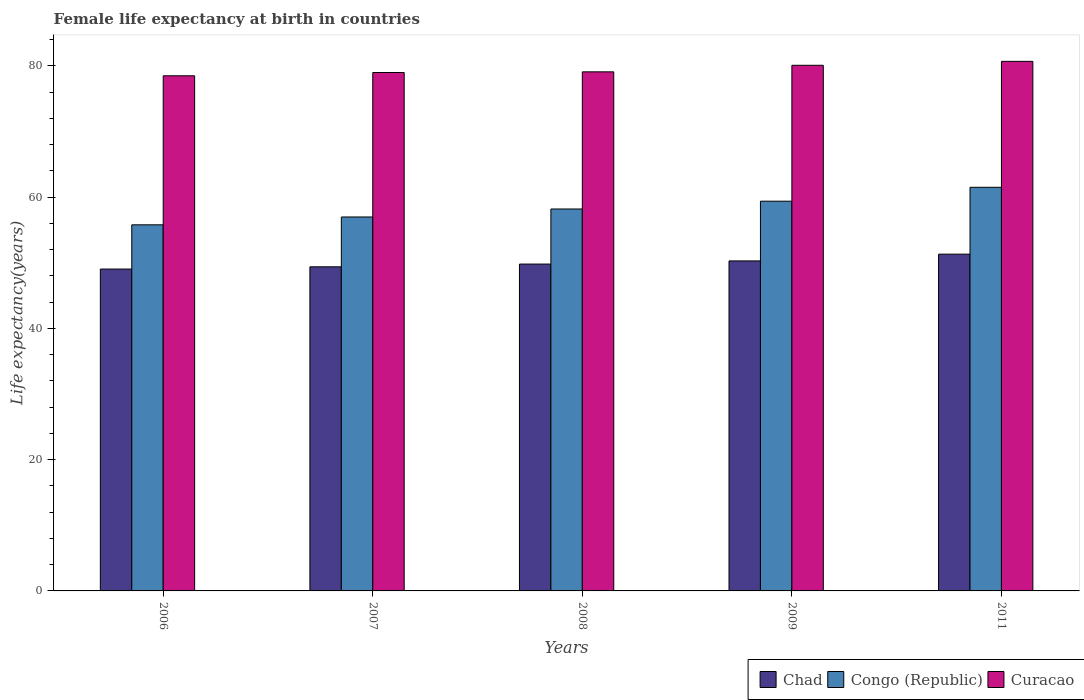How many different coloured bars are there?
Make the answer very short. 3. How many groups of bars are there?
Offer a very short reply. 5. Are the number of bars per tick equal to the number of legend labels?
Make the answer very short. Yes. How many bars are there on the 3rd tick from the left?
Offer a very short reply. 3. How many bars are there on the 2nd tick from the right?
Make the answer very short. 3. What is the label of the 3rd group of bars from the left?
Ensure brevity in your answer.  2008. In how many cases, is the number of bars for a given year not equal to the number of legend labels?
Provide a short and direct response. 0. What is the female life expectancy at birth in Congo (Republic) in 2011?
Give a very brief answer. 61.51. Across all years, what is the maximum female life expectancy at birth in Congo (Republic)?
Offer a very short reply. 61.51. Across all years, what is the minimum female life expectancy at birth in Chad?
Offer a very short reply. 49.05. In which year was the female life expectancy at birth in Curacao maximum?
Your answer should be compact. 2011. In which year was the female life expectancy at birth in Congo (Republic) minimum?
Give a very brief answer. 2006. What is the total female life expectancy at birth in Chad in the graph?
Your answer should be very brief. 249.86. What is the difference between the female life expectancy at birth in Congo (Republic) in 2006 and that in 2009?
Your response must be concise. -3.6. What is the difference between the female life expectancy at birth in Chad in 2007 and the female life expectancy at birth in Curacao in 2009?
Make the answer very short. -30.71. What is the average female life expectancy at birth in Curacao per year?
Offer a very short reply. 79.48. In the year 2009, what is the difference between the female life expectancy at birth in Chad and female life expectancy at birth in Congo (Republic)?
Keep it short and to the point. -9.1. In how many years, is the female life expectancy at birth in Congo (Republic) greater than 44 years?
Make the answer very short. 5. What is the ratio of the female life expectancy at birth in Congo (Republic) in 2007 to that in 2008?
Your response must be concise. 0.98. Is the difference between the female life expectancy at birth in Chad in 2008 and 2011 greater than the difference between the female life expectancy at birth in Congo (Republic) in 2008 and 2011?
Ensure brevity in your answer.  Yes. What is the difference between the highest and the second highest female life expectancy at birth in Curacao?
Offer a very short reply. 0.6. What is the difference between the highest and the lowest female life expectancy at birth in Chad?
Make the answer very short. 2.27. In how many years, is the female life expectancy at birth in Congo (Republic) greater than the average female life expectancy at birth in Congo (Republic) taken over all years?
Offer a very short reply. 2. What does the 2nd bar from the left in 2011 represents?
Make the answer very short. Congo (Republic). What does the 3rd bar from the right in 2008 represents?
Make the answer very short. Chad. How many bars are there?
Offer a terse response. 15. Are all the bars in the graph horizontal?
Provide a succinct answer. No. How many years are there in the graph?
Provide a short and direct response. 5. What is the difference between two consecutive major ticks on the Y-axis?
Provide a succinct answer. 20. Are the values on the major ticks of Y-axis written in scientific E-notation?
Your response must be concise. No. Does the graph contain grids?
Provide a short and direct response. No. Where does the legend appear in the graph?
Provide a succinct answer. Bottom right. How many legend labels are there?
Provide a short and direct response. 3. How are the legend labels stacked?
Offer a very short reply. Horizontal. What is the title of the graph?
Offer a very short reply. Female life expectancy at birth in countries. What is the label or title of the X-axis?
Provide a short and direct response. Years. What is the label or title of the Y-axis?
Ensure brevity in your answer.  Life expectancy(years). What is the Life expectancy(years) in Chad in 2006?
Provide a succinct answer. 49.05. What is the Life expectancy(years) in Congo (Republic) in 2006?
Ensure brevity in your answer.  55.79. What is the Life expectancy(years) in Curacao in 2006?
Ensure brevity in your answer.  78.5. What is the Life expectancy(years) in Chad in 2007?
Offer a very short reply. 49.39. What is the Life expectancy(years) in Congo (Republic) in 2007?
Make the answer very short. 56.98. What is the Life expectancy(years) in Curacao in 2007?
Ensure brevity in your answer.  79. What is the Life expectancy(years) of Chad in 2008?
Your answer should be compact. 49.81. What is the Life expectancy(years) of Congo (Republic) in 2008?
Your response must be concise. 58.2. What is the Life expectancy(years) in Curacao in 2008?
Provide a succinct answer. 79.1. What is the Life expectancy(years) in Chad in 2009?
Your response must be concise. 50.29. What is the Life expectancy(years) in Congo (Republic) in 2009?
Offer a terse response. 59.39. What is the Life expectancy(years) in Curacao in 2009?
Keep it short and to the point. 80.1. What is the Life expectancy(years) in Chad in 2011?
Your answer should be compact. 51.32. What is the Life expectancy(years) of Congo (Republic) in 2011?
Offer a terse response. 61.51. What is the Life expectancy(years) in Curacao in 2011?
Make the answer very short. 80.7. Across all years, what is the maximum Life expectancy(years) of Chad?
Provide a short and direct response. 51.32. Across all years, what is the maximum Life expectancy(years) in Congo (Republic)?
Your response must be concise. 61.51. Across all years, what is the maximum Life expectancy(years) in Curacao?
Provide a succinct answer. 80.7. Across all years, what is the minimum Life expectancy(years) of Chad?
Offer a terse response. 49.05. Across all years, what is the minimum Life expectancy(years) in Congo (Republic)?
Your response must be concise. 55.79. Across all years, what is the minimum Life expectancy(years) in Curacao?
Keep it short and to the point. 78.5. What is the total Life expectancy(years) in Chad in the graph?
Ensure brevity in your answer.  249.86. What is the total Life expectancy(years) in Congo (Republic) in the graph?
Keep it short and to the point. 291.87. What is the total Life expectancy(years) in Curacao in the graph?
Provide a succinct answer. 397.4. What is the difference between the Life expectancy(years) of Chad in 2006 and that in 2007?
Ensure brevity in your answer.  -0.34. What is the difference between the Life expectancy(years) in Congo (Republic) in 2006 and that in 2007?
Keep it short and to the point. -1.2. What is the difference between the Life expectancy(years) in Curacao in 2006 and that in 2007?
Offer a very short reply. -0.5. What is the difference between the Life expectancy(years) in Chad in 2006 and that in 2008?
Your answer should be very brief. -0.76. What is the difference between the Life expectancy(years) in Congo (Republic) in 2006 and that in 2008?
Make the answer very short. -2.41. What is the difference between the Life expectancy(years) of Curacao in 2006 and that in 2008?
Provide a short and direct response. -0.6. What is the difference between the Life expectancy(years) of Chad in 2006 and that in 2009?
Your answer should be very brief. -1.24. What is the difference between the Life expectancy(years) of Congo (Republic) in 2006 and that in 2009?
Your response must be concise. -3.6. What is the difference between the Life expectancy(years) in Chad in 2006 and that in 2011?
Your answer should be very brief. -2.27. What is the difference between the Life expectancy(years) of Congo (Republic) in 2006 and that in 2011?
Provide a short and direct response. -5.72. What is the difference between the Life expectancy(years) in Chad in 2007 and that in 2008?
Provide a succinct answer. -0.42. What is the difference between the Life expectancy(years) in Congo (Republic) in 2007 and that in 2008?
Keep it short and to the point. -1.22. What is the difference between the Life expectancy(years) of Curacao in 2007 and that in 2008?
Ensure brevity in your answer.  -0.1. What is the difference between the Life expectancy(years) in Chad in 2007 and that in 2009?
Offer a very short reply. -0.9. What is the difference between the Life expectancy(years) of Congo (Republic) in 2007 and that in 2009?
Provide a succinct answer. -2.4. What is the difference between the Life expectancy(years) of Curacao in 2007 and that in 2009?
Offer a very short reply. -1.1. What is the difference between the Life expectancy(years) in Chad in 2007 and that in 2011?
Ensure brevity in your answer.  -1.93. What is the difference between the Life expectancy(years) of Congo (Republic) in 2007 and that in 2011?
Your answer should be very brief. -4.52. What is the difference between the Life expectancy(years) of Chad in 2008 and that in 2009?
Provide a short and direct response. -0.48. What is the difference between the Life expectancy(years) of Congo (Republic) in 2008 and that in 2009?
Offer a very short reply. -1.19. What is the difference between the Life expectancy(years) in Chad in 2008 and that in 2011?
Offer a terse response. -1.51. What is the difference between the Life expectancy(years) of Congo (Republic) in 2008 and that in 2011?
Offer a terse response. -3.31. What is the difference between the Life expectancy(years) in Curacao in 2008 and that in 2011?
Make the answer very short. -1.6. What is the difference between the Life expectancy(years) in Chad in 2009 and that in 2011?
Provide a short and direct response. -1.03. What is the difference between the Life expectancy(years) of Congo (Republic) in 2009 and that in 2011?
Keep it short and to the point. -2.12. What is the difference between the Life expectancy(years) of Curacao in 2009 and that in 2011?
Your answer should be very brief. -0.6. What is the difference between the Life expectancy(years) of Chad in 2006 and the Life expectancy(years) of Congo (Republic) in 2007?
Provide a succinct answer. -7.94. What is the difference between the Life expectancy(years) in Chad in 2006 and the Life expectancy(years) in Curacao in 2007?
Your answer should be compact. -29.95. What is the difference between the Life expectancy(years) in Congo (Republic) in 2006 and the Life expectancy(years) in Curacao in 2007?
Your answer should be compact. -23.21. What is the difference between the Life expectancy(years) in Chad in 2006 and the Life expectancy(years) in Congo (Republic) in 2008?
Your answer should be very brief. -9.15. What is the difference between the Life expectancy(years) of Chad in 2006 and the Life expectancy(years) of Curacao in 2008?
Your answer should be compact. -30.05. What is the difference between the Life expectancy(years) in Congo (Republic) in 2006 and the Life expectancy(years) in Curacao in 2008?
Keep it short and to the point. -23.31. What is the difference between the Life expectancy(years) in Chad in 2006 and the Life expectancy(years) in Congo (Republic) in 2009?
Provide a succinct answer. -10.34. What is the difference between the Life expectancy(years) in Chad in 2006 and the Life expectancy(years) in Curacao in 2009?
Provide a short and direct response. -31.05. What is the difference between the Life expectancy(years) of Congo (Republic) in 2006 and the Life expectancy(years) of Curacao in 2009?
Offer a very short reply. -24.31. What is the difference between the Life expectancy(years) of Chad in 2006 and the Life expectancy(years) of Congo (Republic) in 2011?
Offer a terse response. -12.46. What is the difference between the Life expectancy(years) of Chad in 2006 and the Life expectancy(years) of Curacao in 2011?
Offer a terse response. -31.65. What is the difference between the Life expectancy(years) of Congo (Republic) in 2006 and the Life expectancy(years) of Curacao in 2011?
Provide a succinct answer. -24.91. What is the difference between the Life expectancy(years) in Chad in 2007 and the Life expectancy(years) in Congo (Republic) in 2008?
Keep it short and to the point. -8.81. What is the difference between the Life expectancy(years) of Chad in 2007 and the Life expectancy(years) of Curacao in 2008?
Your response must be concise. -29.71. What is the difference between the Life expectancy(years) in Congo (Republic) in 2007 and the Life expectancy(years) in Curacao in 2008?
Your answer should be very brief. -22.11. What is the difference between the Life expectancy(years) in Chad in 2007 and the Life expectancy(years) in Curacao in 2009?
Make the answer very short. -30.71. What is the difference between the Life expectancy(years) of Congo (Republic) in 2007 and the Life expectancy(years) of Curacao in 2009?
Your response must be concise. -23.11. What is the difference between the Life expectancy(years) in Chad in 2007 and the Life expectancy(years) in Congo (Republic) in 2011?
Keep it short and to the point. -12.12. What is the difference between the Life expectancy(years) in Chad in 2007 and the Life expectancy(years) in Curacao in 2011?
Your answer should be compact. -31.31. What is the difference between the Life expectancy(years) in Congo (Republic) in 2007 and the Life expectancy(years) in Curacao in 2011?
Your response must be concise. -23.71. What is the difference between the Life expectancy(years) in Chad in 2008 and the Life expectancy(years) in Congo (Republic) in 2009?
Keep it short and to the point. -9.58. What is the difference between the Life expectancy(years) of Chad in 2008 and the Life expectancy(years) of Curacao in 2009?
Make the answer very short. -30.29. What is the difference between the Life expectancy(years) of Congo (Republic) in 2008 and the Life expectancy(years) of Curacao in 2009?
Provide a succinct answer. -21.9. What is the difference between the Life expectancy(years) in Chad in 2008 and the Life expectancy(years) in Congo (Republic) in 2011?
Make the answer very short. -11.7. What is the difference between the Life expectancy(years) of Chad in 2008 and the Life expectancy(years) of Curacao in 2011?
Make the answer very short. -30.89. What is the difference between the Life expectancy(years) in Congo (Republic) in 2008 and the Life expectancy(years) in Curacao in 2011?
Your response must be concise. -22.5. What is the difference between the Life expectancy(years) in Chad in 2009 and the Life expectancy(years) in Congo (Republic) in 2011?
Offer a very short reply. -11.22. What is the difference between the Life expectancy(years) of Chad in 2009 and the Life expectancy(years) of Curacao in 2011?
Your answer should be compact. -30.41. What is the difference between the Life expectancy(years) in Congo (Republic) in 2009 and the Life expectancy(years) in Curacao in 2011?
Provide a succinct answer. -21.31. What is the average Life expectancy(years) of Chad per year?
Give a very brief answer. 49.97. What is the average Life expectancy(years) of Congo (Republic) per year?
Your response must be concise. 58.37. What is the average Life expectancy(years) of Curacao per year?
Give a very brief answer. 79.48. In the year 2006, what is the difference between the Life expectancy(years) in Chad and Life expectancy(years) in Congo (Republic)?
Provide a short and direct response. -6.74. In the year 2006, what is the difference between the Life expectancy(years) in Chad and Life expectancy(years) in Curacao?
Provide a succinct answer. -29.45. In the year 2006, what is the difference between the Life expectancy(years) in Congo (Republic) and Life expectancy(years) in Curacao?
Make the answer very short. -22.71. In the year 2007, what is the difference between the Life expectancy(years) of Chad and Life expectancy(years) of Congo (Republic)?
Your answer should be very brief. -7.59. In the year 2007, what is the difference between the Life expectancy(years) in Chad and Life expectancy(years) in Curacao?
Provide a short and direct response. -29.61. In the year 2007, what is the difference between the Life expectancy(years) in Congo (Republic) and Life expectancy(years) in Curacao?
Offer a very short reply. -22.02. In the year 2008, what is the difference between the Life expectancy(years) of Chad and Life expectancy(years) of Congo (Republic)?
Make the answer very short. -8.39. In the year 2008, what is the difference between the Life expectancy(years) in Chad and Life expectancy(years) in Curacao?
Your answer should be compact. -29.29. In the year 2008, what is the difference between the Life expectancy(years) of Congo (Republic) and Life expectancy(years) of Curacao?
Ensure brevity in your answer.  -20.9. In the year 2009, what is the difference between the Life expectancy(years) of Chad and Life expectancy(years) of Congo (Republic)?
Give a very brief answer. -9.1. In the year 2009, what is the difference between the Life expectancy(years) in Chad and Life expectancy(years) in Curacao?
Give a very brief answer. -29.81. In the year 2009, what is the difference between the Life expectancy(years) in Congo (Republic) and Life expectancy(years) in Curacao?
Offer a terse response. -20.71. In the year 2011, what is the difference between the Life expectancy(years) in Chad and Life expectancy(years) in Congo (Republic)?
Your answer should be very brief. -10.19. In the year 2011, what is the difference between the Life expectancy(years) of Chad and Life expectancy(years) of Curacao?
Make the answer very short. -29.38. In the year 2011, what is the difference between the Life expectancy(years) of Congo (Republic) and Life expectancy(years) of Curacao?
Your response must be concise. -19.19. What is the ratio of the Life expectancy(years) of Curacao in 2006 to that in 2007?
Your answer should be very brief. 0.99. What is the ratio of the Life expectancy(years) in Chad in 2006 to that in 2008?
Provide a short and direct response. 0.98. What is the ratio of the Life expectancy(years) in Congo (Republic) in 2006 to that in 2008?
Offer a very short reply. 0.96. What is the ratio of the Life expectancy(years) in Chad in 2006 to that in 2009?
Offer a very short reply. 0.98. What is the ratio of the Life expectancy(years) in Congo (Republic) in 2006 to that in 2009?
Your answer should be very brief. 0.94. What is the ratio of the Life expectancy(years) of Chad in 2006 to that in 2011?
Your answer should be compact. 0.96. What is the ratio of the Life expectancy(years) in Congo (Republic) in 2006 to that in 2011?
Your response must be concise. 0.91. What is the ratio of the Life expectancy(years) of Curacao in 2006 to that in 2011?
Offer a terse response. 0.97. What is the ratio of the Life expectancy(years) of Congo (Republic) in 2007 to that in 2008?
Offer a terse response. 0.98. What is the ratio of the Life expectancy(years) of Curacao in 2007 to that in 2008?
Give a very brief answer. 1. What is the ratio of the Life expectancy(years) in Chad in 2007 to that in 2009?
Your answer should be very brief. 0.98. What is the ratio of the Life expectancy(years) in Congo (Republic) in 2007 to that in 2009?
Offer a terse response. 0.96. What is the ratio of the Life expectancy(years) in Curacao in 2007 to that in 2009?
Ensure brevity in your answer.  0.99. What is the ratio of the Life expectancy(years) in Chad in 2007 to that in 2011?
Provide a succinct answer. 0.96. What is the ratio of the Life expectancy(years) of Congo (Republic) in 2007 to that in 2011?
Ensure brevity in your answer.  0.93. What is the ratio of the Life expectancy(years) in Curacao in 2007 to that in 2011?
Provide a short and direct response. 0.98. What is the ratio of the Life expectancy(years) of Chad in 2008 to that in 2009?
Ensure brevity in your answer.  0.99. What is the ratio of the Life expectancy(years) of Curacao in 2008 to that in 2009?
Ensure brevity in your answer.  0.99. What is the ratio of the Life expectancy(years) of Chad in 2008 to that in 2011?
Your response must be concise. 0.97. What is the ratio of the Life expectancy(years) of Congo (Republic) in 2008 to that in 2011?
Ensure brevity in your answer.  0.95. What is the ratio of the Life expectancy(years) of Curacao in 2008 to that in 2011?
Keep it short and to the point. 0.98. What is the ratio of the Life expectancy(years) of Chad in 2009 to that in 2011?
Make the answer very short. 0.98. What is the ratio of the Life expectancy(years) of Congo (Republic) in 2009 to that in 2011?
Your response must be concise. 0.97. What is the difference between the highest and the second highest Life expectancy(years) of Chad?
Offer a very short reply. 1.03. What is the difference between the highest and the second highest Life expectancy(years) in Congo (Republic)?
Your response must be concise. 2.12. What is the difference between the highest and the second highest Life expectancy(years) in Curacao?
Offer a terse response. 0.6. What is the difference between the highest and the lowest Life expectancy(years) of Chad?
Your answer should be very brief. 2.27. What is the difference between the highest and the lowest Life expectancy(years) in Congo (Republic)?
Your response must be concise. 5.72. What is the difference between the highest and the lowest Life expectancy(years) in Curacao?
Your answer should be very brief. 2.2. 